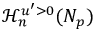<formula> <loc_0><loc_0><loc_500><loc_500>\mathcal { H } _ { n } ^ { u ^ { \prime } > 0 } ( N _ { p } )</formula> 